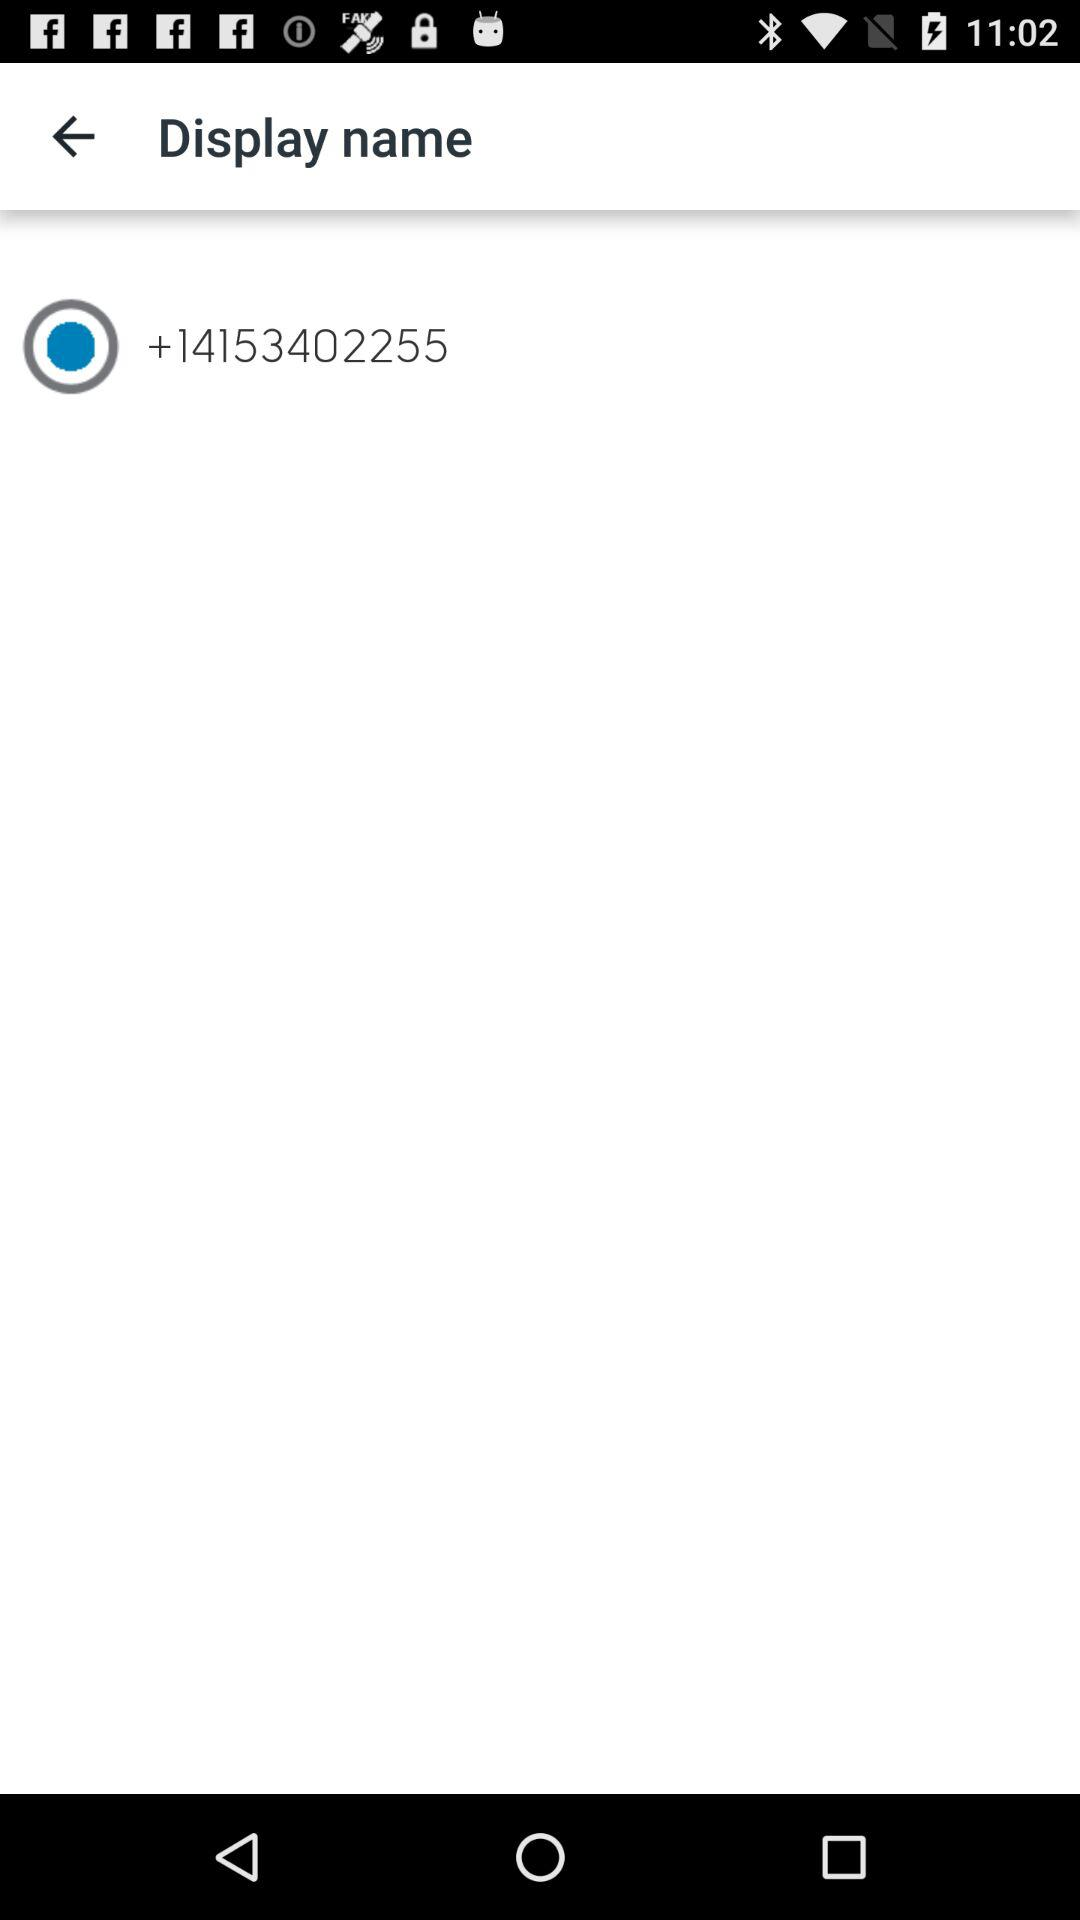What is the selected phone number? The selected phone number is +14153402255. 